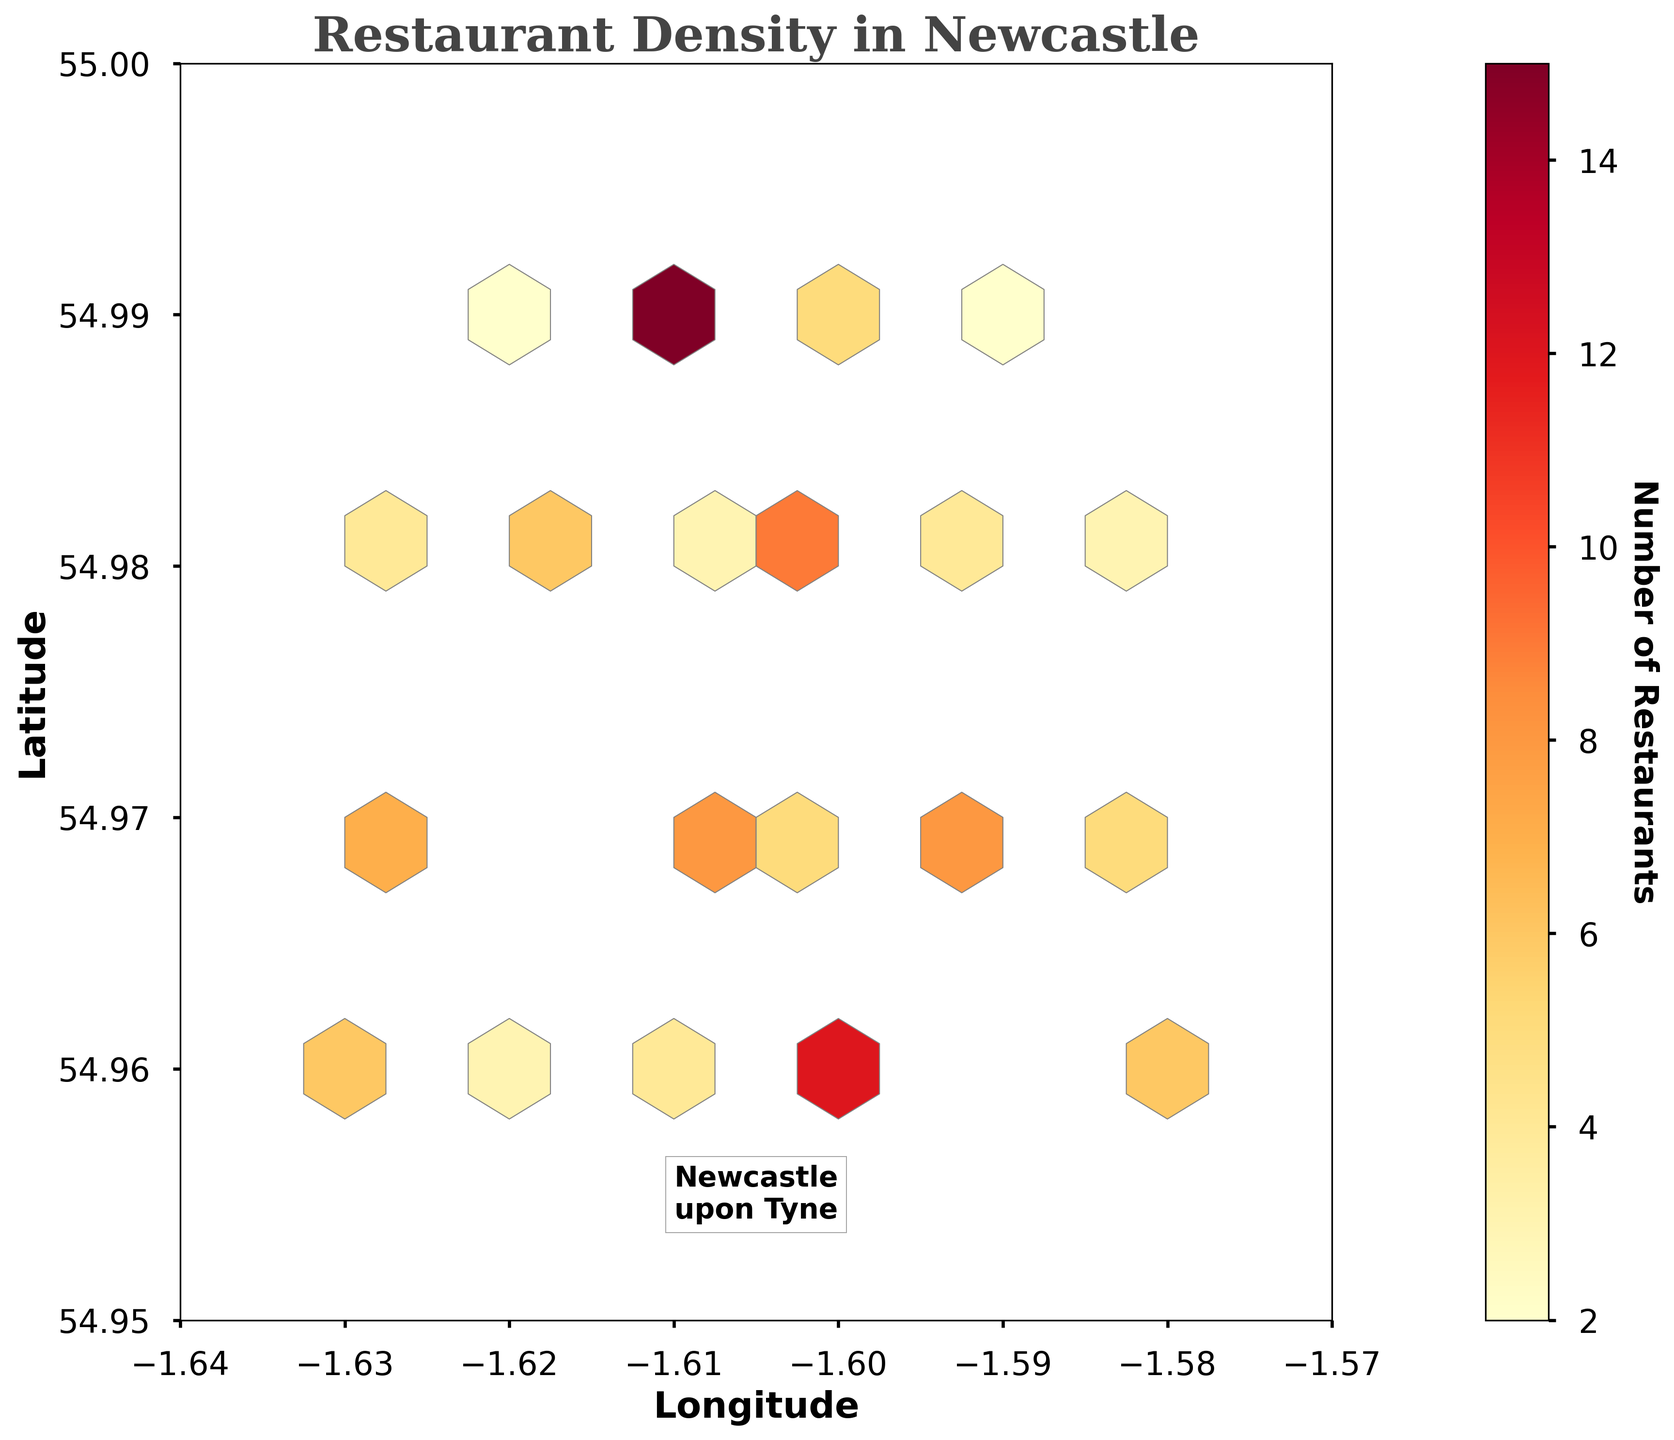What is the title of the Hexbin Plot? The title of the plot is prominently displayed at the top of the figure. It usually provides a summary of the main theme or focus of the graph. In this case, it tells us what the plot is about.
Answer: Restaurant Density in Newcastle How is the color scale represented in the Hexbin Plot? The color scale is shown using a color bar, which is a vertical bar adjacent to the plot. It uses different shades of a color to indicate varying levels of density, with a label at the top or bottom specifying what the colors represent.
Answer: A color bar next to the plot Which area has the highest density of restaurants according to the Hexbin Plot? By examining the plot, the hexbin with the darkest color indicates the highest density of restaurants. You can find this hexbin by locating the darkest shaded hexagon on the plot.
Answer: Around coordinates (-1.61, 54.99) What coordinates on the plot have the lowest density of restaurants? To find the area with the lowest density, look for the hexagons with the lightest color or no shading at all. These areas represent the lowest density of restaurants.
Answer: Areas without color or very light-shaded hexagons How many distinct types of restaurants are represented in the data? To determine the number of distinct types, count the unique restaurant types mentioned in the data. This can be inferred from the different types of restaurants plotted on the hexbin graph.
Answer: 19 distinct types Which two restaurant types have the highest density and how do they compare? First, identify the restaurant types with the highest counts in the given coordinates. Compare the densities by looking at the hexagons in the plot where these restaurant types are located. The density can be inferred from the color intensity in those areas.
Answer: Pub Food and British; Pub Food has a slightly higher density In which neighborhood can you find a density of Mediterranean restaurants? By locating the coordinates linked with Mediterranean restaurants on the hexbin plot, you can determine the neighborhood. Mediterranean restaurants are placed at specific coordinates within the plot.
Answer: Around coordinates (-1.58, 54.97) What is the range of the longitude and latitude in the Hexbin Plot? To find the range, look at the x-axis and y-axis labels. Note the minimum and maximum values marked on these axes, as these represent the range of the longitude and latitude in the plot.
Answer: Longitude: -1.64 to -1.57, Latitude: 54.95 to 55.00 Which neighborhood has the most variety of restaurant types? To find the neighborhood with the most variety, examine the plot to identify which region (or hexagon) has the most different colors (or types of restaurants) clustered together.
Answer: Around coordinates (-1.61, 54.98) What is the total count of restaurants represented within the plot? Sum up all the counts provided in the data to get the total number of restaurants. This requires adding all the `count` values for each restaurant type.
Answer: Total count is 104 